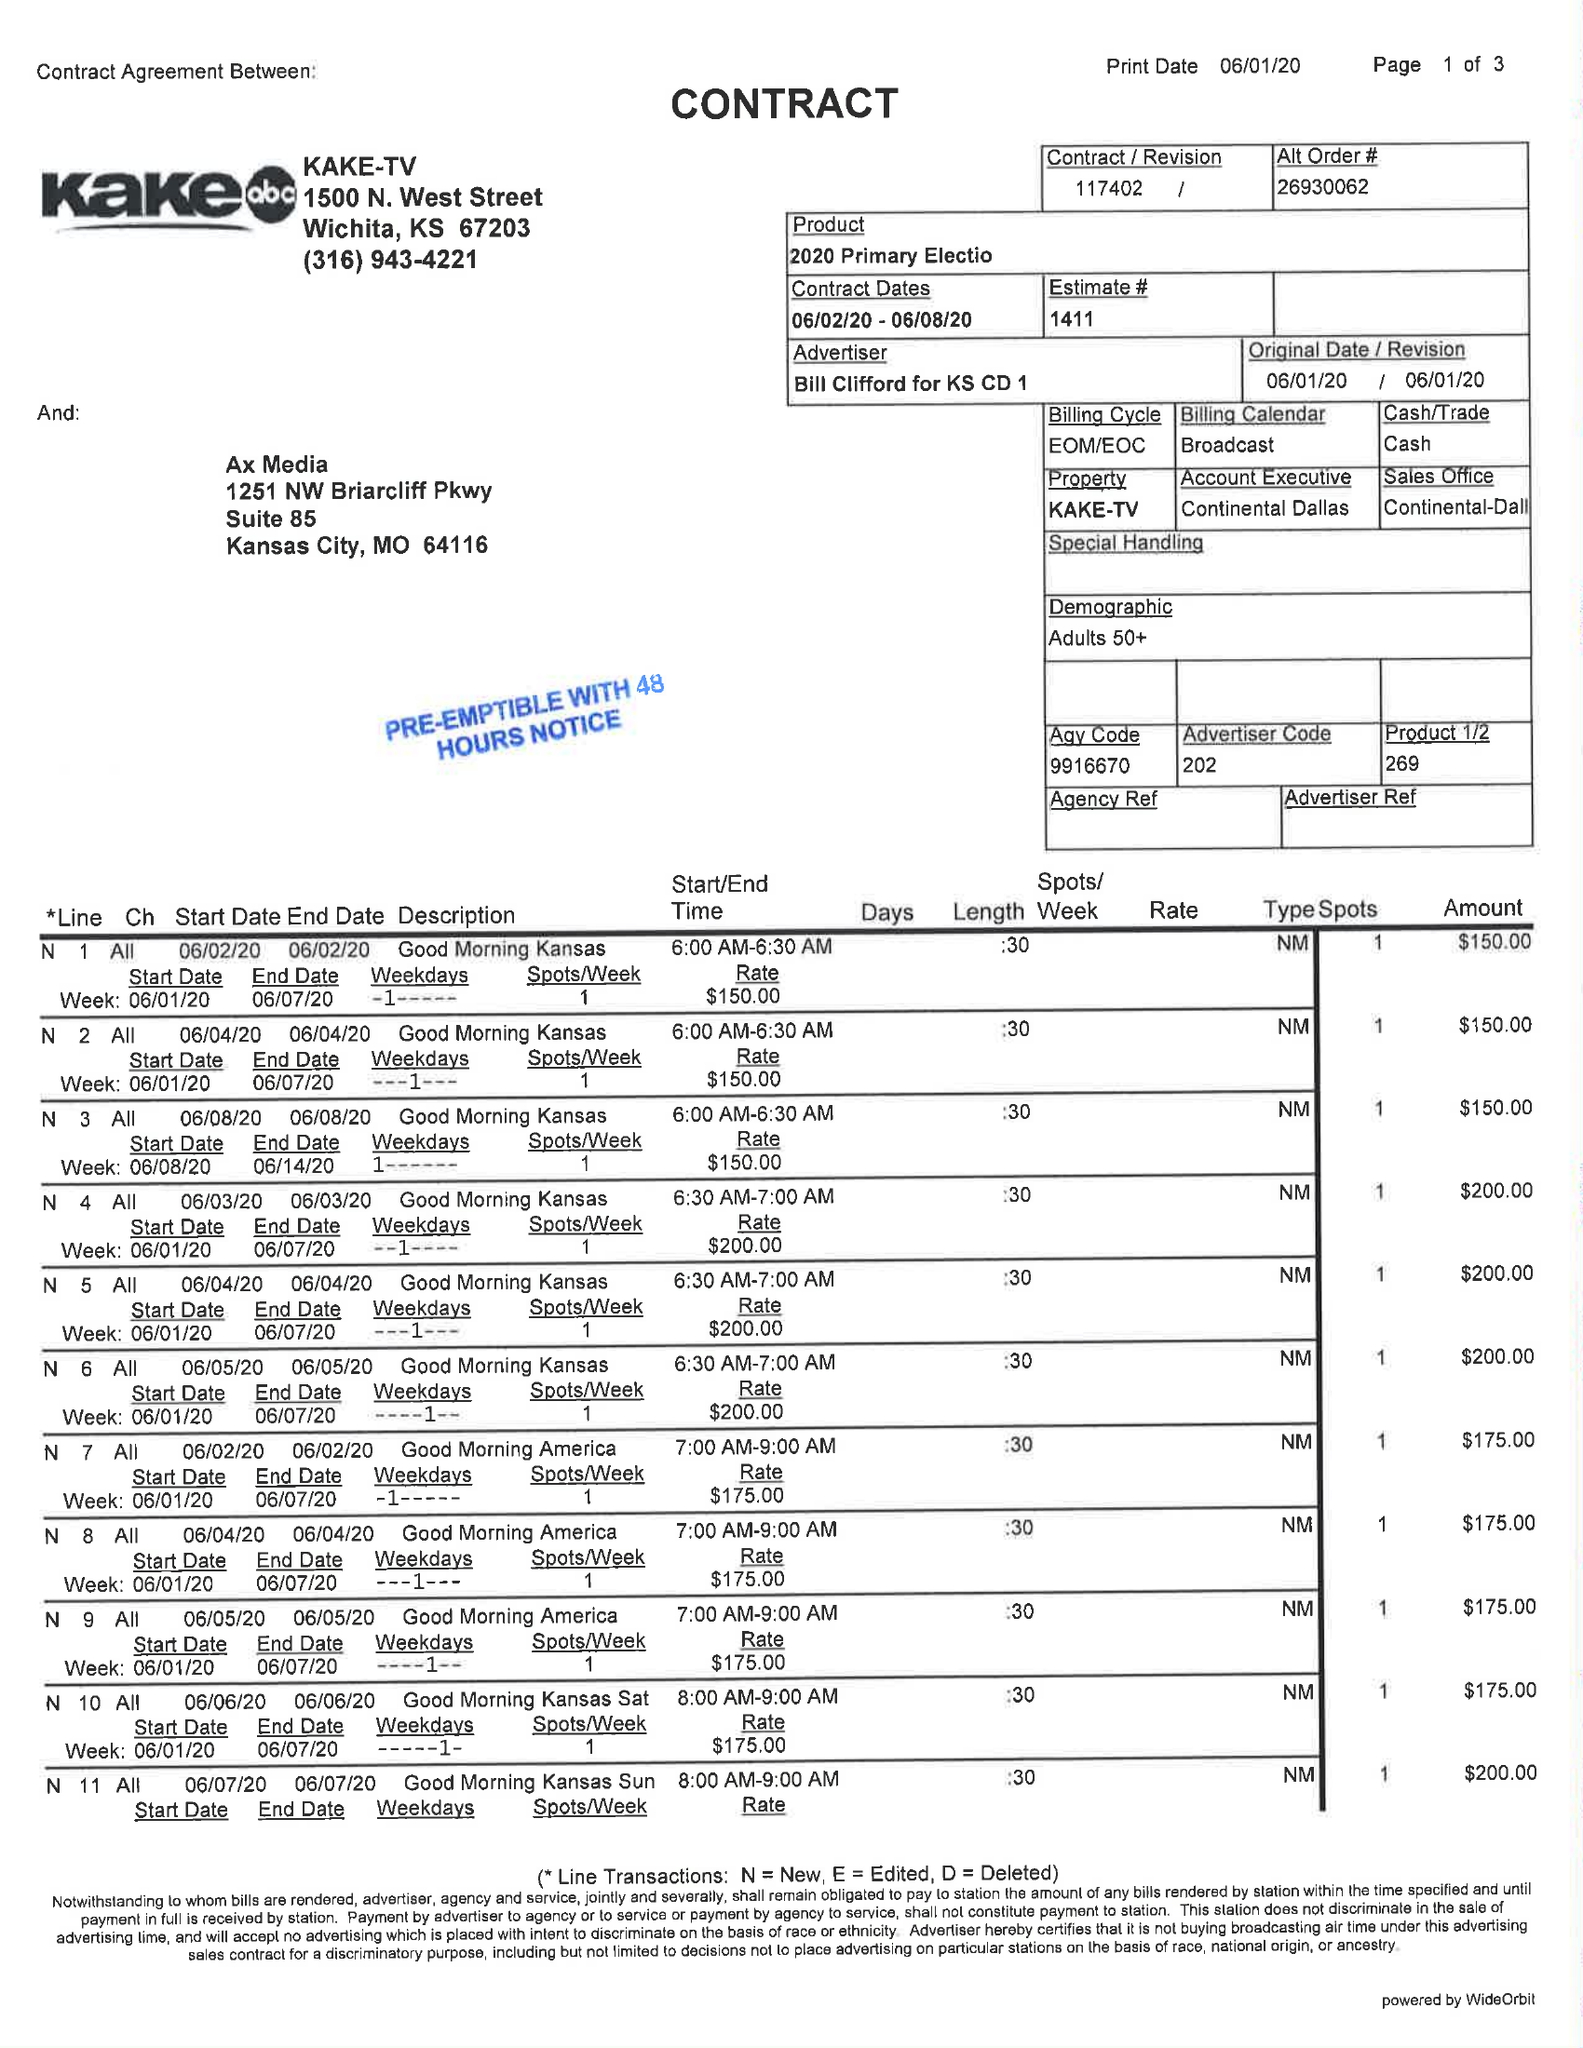What is the value for the advertiser?
Answer the question using a single word or phrase. BILL CLIFFORD FOR KS CD 1 